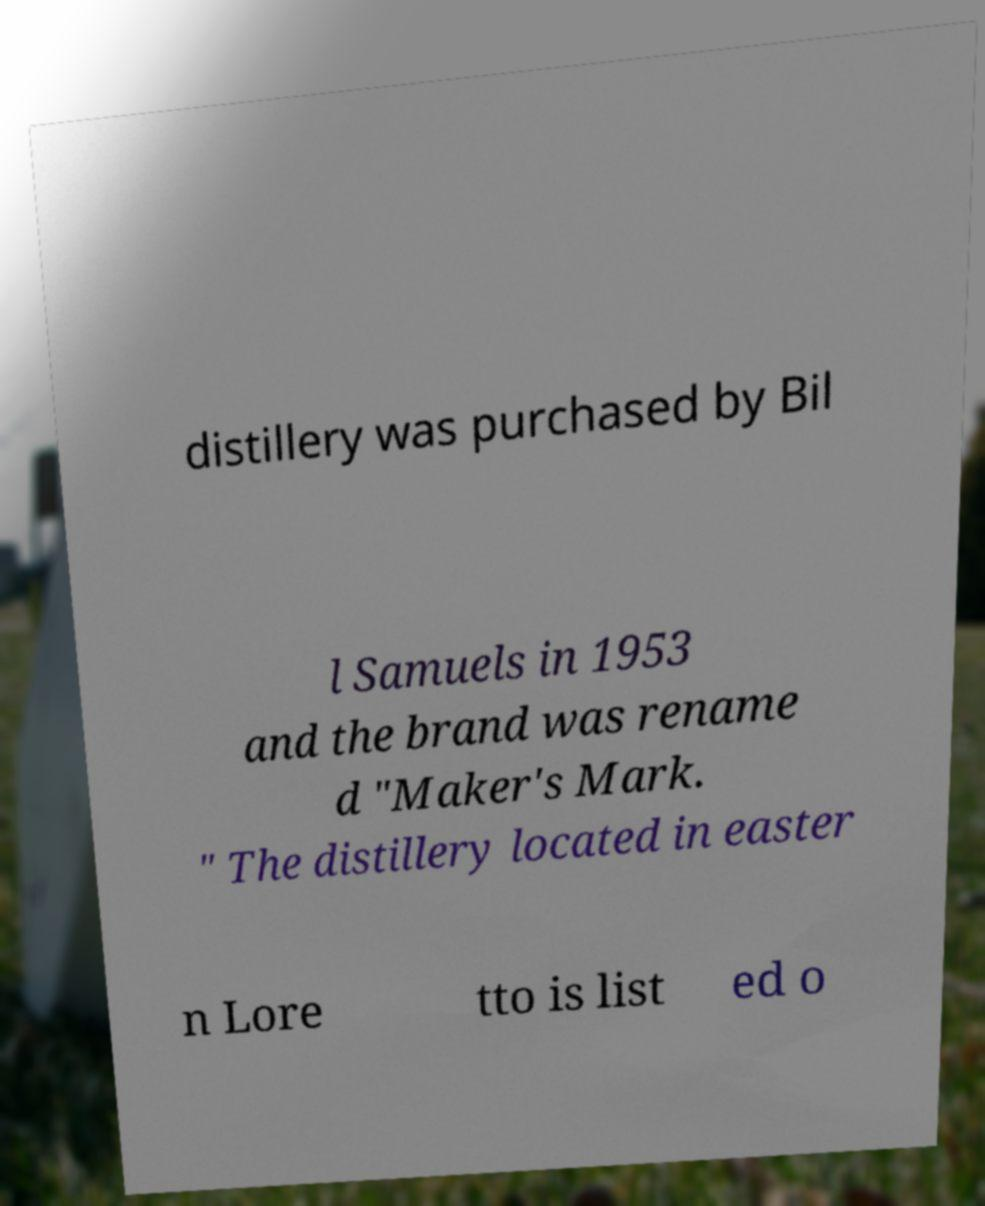Please read and relay the text visible in this image. What does it say? distillery was purchased by Bil l Samuels in 1953 and the brand was rename d "Maker's Mark. " The distillery located in easter n Lore tto is list ed o 